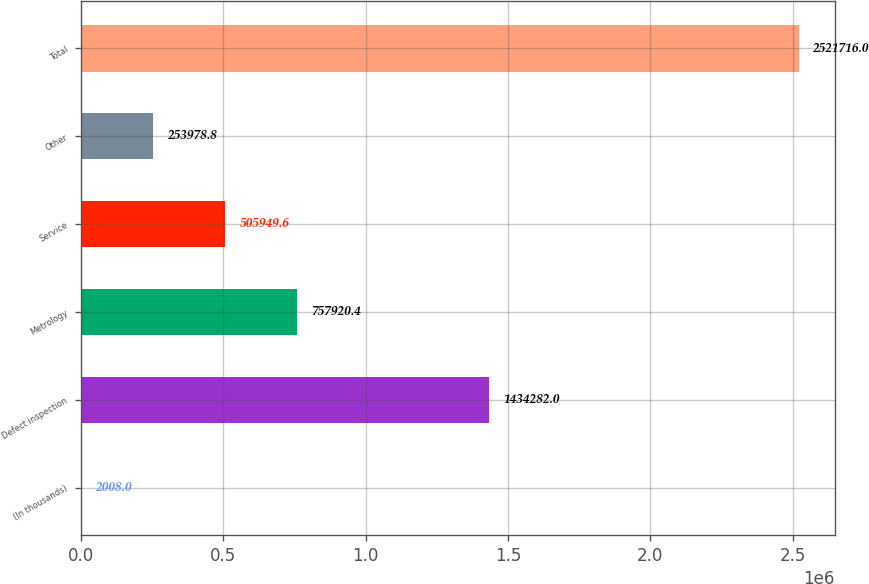<chart> <loc_0><loc_0><loc_500><loc_500><bar_chart><fcel>(In thousands)<fcel>Defect inspection<fcel>Metrology<fcel>Service<fcel>Other<fcel>Total<nl><fcel>2008<fcel>1.43428e+06<fcel>757920<fcel>505950<fcel>253979<fcel>2.52172e+06<nl></chart> 